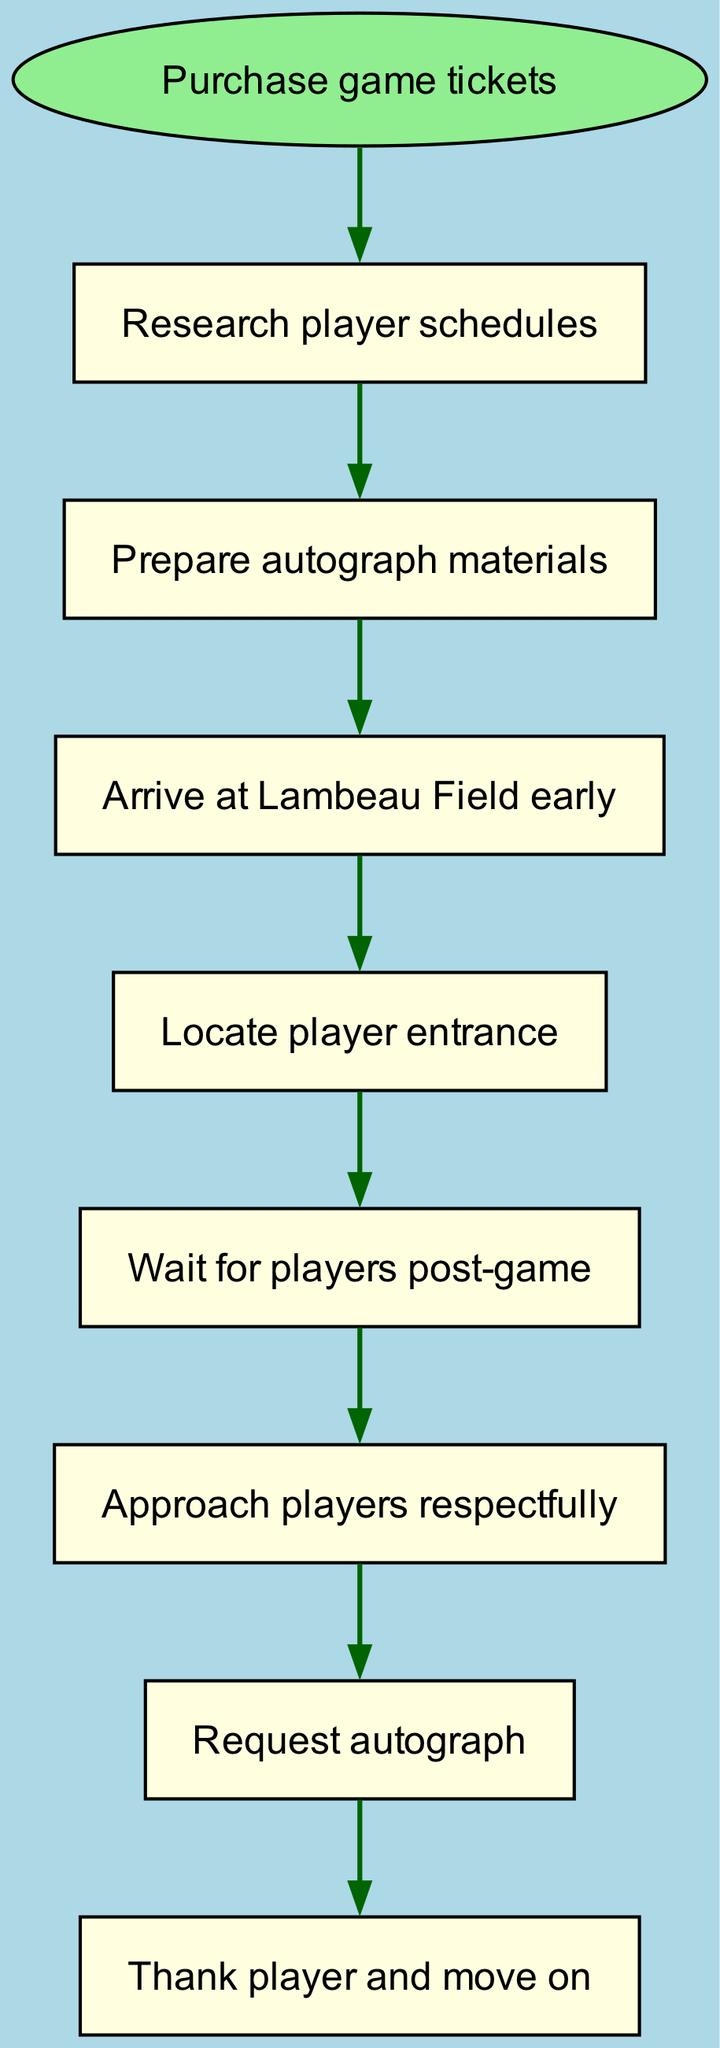What is the first step in planning an autograph hunting trip? The first step is represented by the start node, which is "Purchase game tickets." This node indicates the beginning of the flow before any actions or preparations are made.
Answer: Purchase game tickets How many nodes are in the diagram? The diagram lists all the activities involved in the trip, including the starting point. Counting these nodes gives us a total of eight distinct activities.
Answer: 8 What do you need to do after preparing autograph materials? After preparing autograph materials, the next action in the flow is to "Arrive at Lambeau Field early." This is the subsequent step highlighted in the diagram.
Answer: Arrive at Lambeau Field early Which two nodes are directly connected to "Wait for players post-game"? The node "Wait for players post-game" is connected to two other nodes: "Locate player entrance" (before) and "Approach players respectfully" (after). These connections show the flow of activities leading to and following this stage.
Answer: Locate player entrance, Approach players respectfully What is the final action to take after requesting an autograph? The final action after requesting an autograph is to "Thank player and move on." This indicates the conclusion of the interaction process shown in the flowchart.
Answer: Thank player and move on How many edges connect the nodes in this diagram? Each connection between nodes is represented by an edge. By counting the edges that connect the eight nodes, we find that there are seven edges in total, showing the sequence of actions.
Answer: 7 Which node follows "Locate player entrance"? The node that follows "Locate player entrance" is "Wait for players post-game." This shows the progression from locating the entrance to preparing for player interaction afterward.
Answer: Wait for players post-game What is the relationship between "Research player schedules" and "Prepare autograph materials"? The relationship is sequential; "Research player schedules" leads to "Prepare autograph materials," indicating that the scheduling information is essential for preparing the materials.
Answer: Prepare autograph materials 